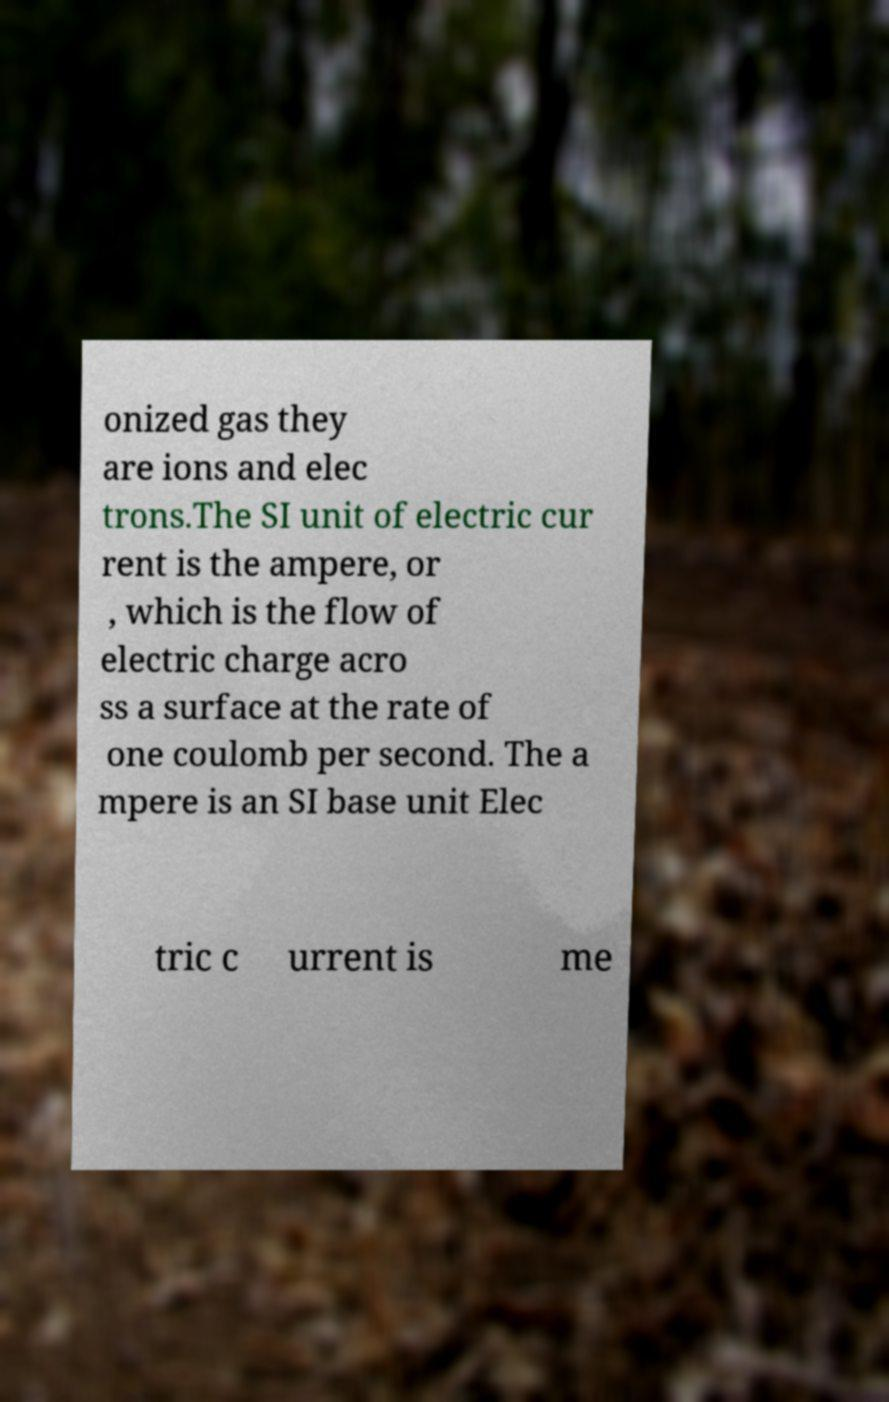Please identify and transcribe the text found in this image. onized gas they are ions and elec trons.The SI unit of electric cur rent is the ampere, or , which is the flow of electric charge acro ss a surface at the rate of one coulomb per second. The a mpere is an SI base unit Elec tric c urrent is me 